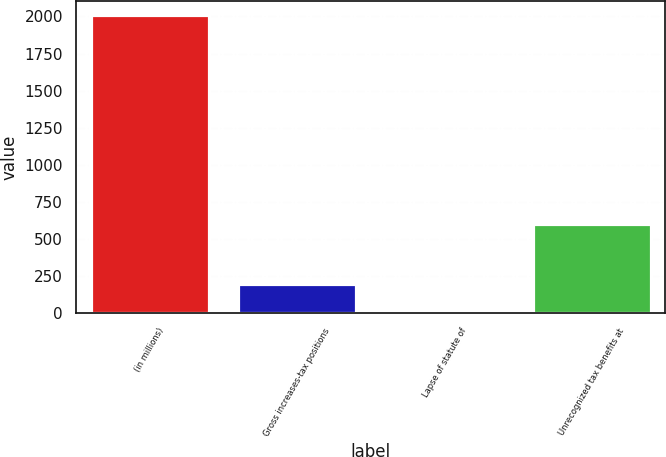<chart> <loc_0><loc_0><loc_500><loc_500><bar_chart><fcel>(in millions)<fcel>Gross increases-tax positions<fcel>Lapse of statute of<fcel>Unrecognized tax benefits at<nl><fcel>2007<fcel>200.79<fcel>0.1<fcel>602.17<nl></chart> 